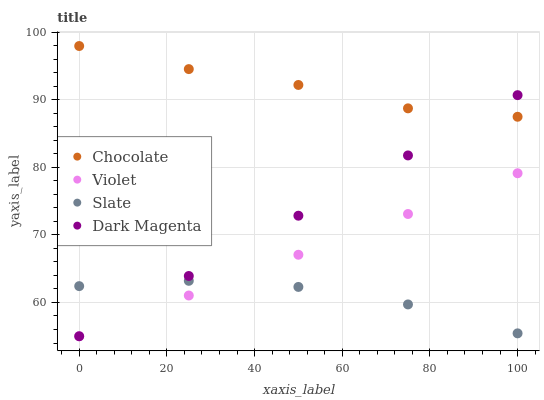Does Slate have the minimum area under the curve?
Answer yes or no. Yes. Does Chocolate have the maximum area under the curve?
Answer yes or no. Yes. Does Violet have the minimum area under the curve?
Answer yes or no. No. Does Violet have the maximum area under the curve?
Answer yes or no. No. Is Dark Magenta the smoothest?
Answer yes or no. Yes. Is Slate the roughest?
Answer yes or no. Yes. Is Violet the smoothest?
Answer yes or no. No. Is Violet the roughest?
Answer yes or no. No. Does Violet have the lowest value?
Answer yes or no. Yes. Does Chocolate have the lowest value?
Answer yes or no. No. Does Chocolate have the highest value?
Answer yes or no. Yes. Does Violet have the highest value?
Answer yes or no. No. Is Slate less than Chocolate?
Answer yes or no. Yes. Is Chocolate greater than Slate?
Answer yes or no. Yes. Does Dark Magenta intersect Violet?
Answer yes or no. Yes. Is Dark Magenta less than Violet?
Answer yes or no. No. Is Dark Magenta greater than Violet?
Answer yes or no. No. Does Slate intersect Chocolate?
Answer yes or no. No. 